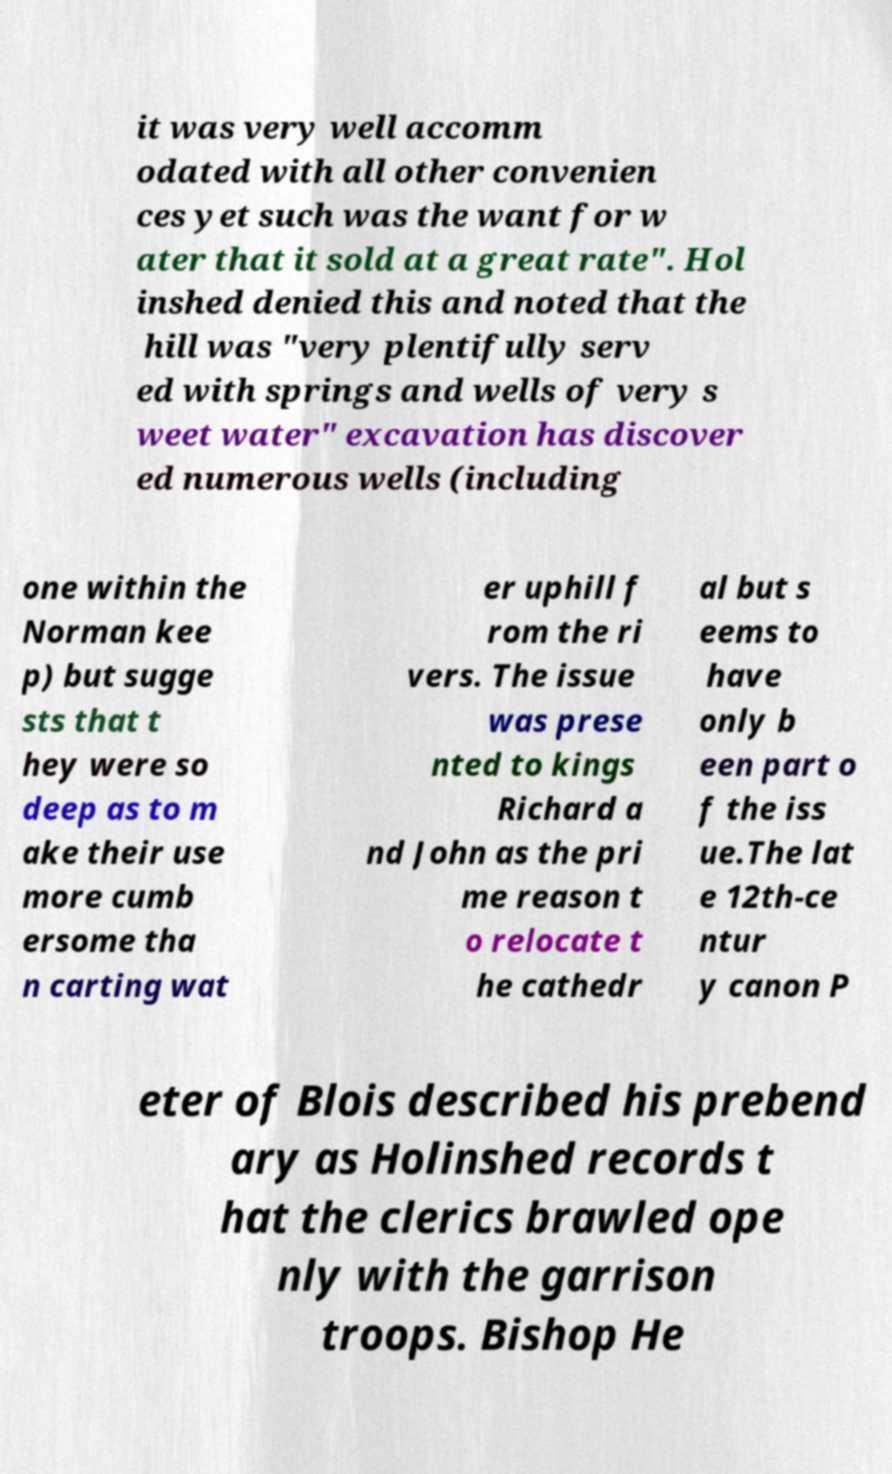For documentation purposes, I need the text within this image transcribed. Could you provide that? it was very well accomm odated with all other convenien ces yet such was the want for w ater that it sold at a great rate". Hol inshed denied this and noted that the hill was "very plentifully serv ed with springs and wells of very s weet water" excavation has discover ed numerous wells (including one within the Norman kee p) but sugge sts that t hey were so deep as to m ake their use more cumb ersome tha n carting wat er uphill f rom the ri vers. The issue was prese nted to kings Richard a nd John as the pri me reason t o relocate t he cathedr al but s eems to have only b een part o f the iss ue.The lat e 12th-ce ntur y canon P eter of Blois described his prebend ary as Holinshed records t hat the clerics brawled ope nly with the garrison troops. Bishop He 